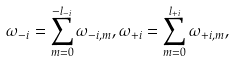Convert formula to latex. <formula><loc_0><loc_0><loc_500><loc_500>\omega _ { - i } = \sum _ { m = 0 } ^ { - l _ { - i } } \omega _ { - i , m } , \omega _ { + i } = \sum _ { m = 0 } ^ { l _ { + i } } \omega _ { + i , m } ,</formula> 